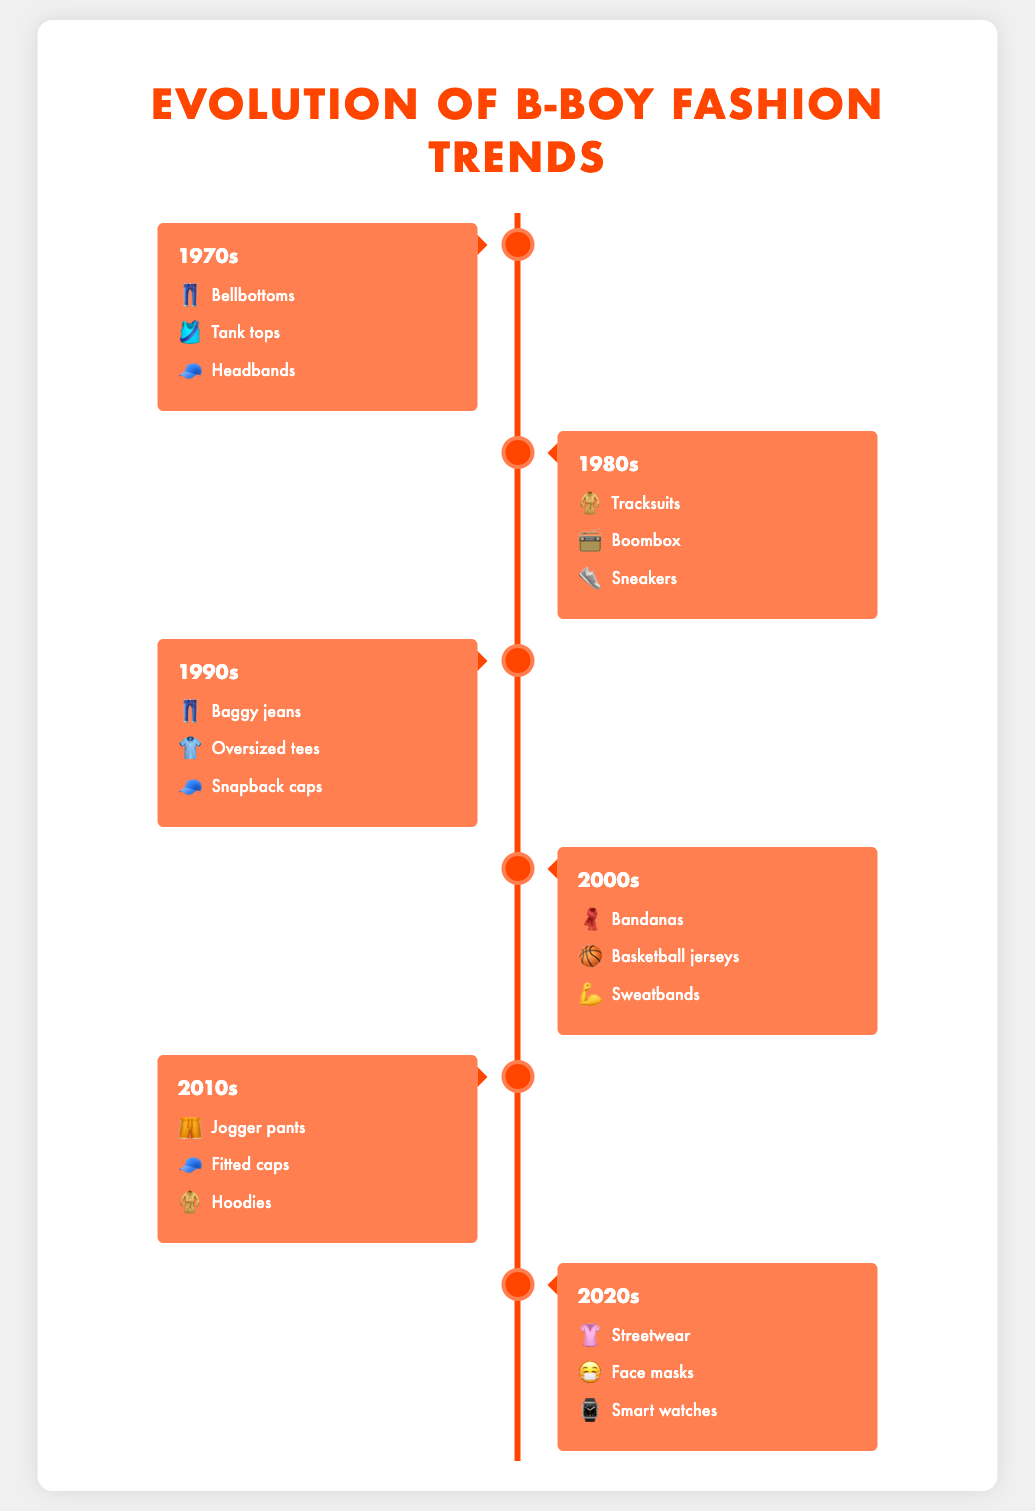Which era is associated with "Baggy jeans" 👖? In the figure, look for the decade that lists "Baggy jeans" along with its emoji.
Answer: 1990s In which era did "Hoodies" 🧥 become a trend? Scan each decade's fashion trends for "Hoodies" and its corresponding emoji.
Answer: 2010s Which items are trending in the 2020s era? Inspect the section labeled "2020s" to see the listed fashion items and their emojis.
Answer: Streetwear 👚, Face masks 😷, Smart watches ⌚ Compare the fashion item of 1970s and 2010s that shares the same emoji 🧢. Which item is it? Look at the items of 1970s and 2010s that use the emoji 🧢 and compare their names.
Answer: Headbands (1970s) and Fitted caps (2010s) How many distinct fashion items are mentioned in the 1980s era? Count the number of items listed under the "1980s" section.
Answer: 3 Identify the two eras where "Tracksuits" 🧥 and "Hoodies"🧥 were popular. Find the decades listing "Tracksuits" and "Hoodies" and note their respective eras.
Answer: Tracksuits: 1980s, Hoodies: 2010s Which era has an item associated with boombox 📻? Look through each decade till you find the fashion item "Boombox" and its emoji.
Answer: 1980s What common theme do the fashion items of the 2000s have compared to those of the 2020s? Evaluate the items of both eras and identify trends or elements that are prevalent in both.
Answer: Sports and accessory elements (2000s: Bandanas, Basketball jerseys, Sweatbands; 2020s: Streetwear, Face masks, Smart watches) Which eras feature headwear items, and what are the items? Look for all decades that list headwear items like caps, headbands, etc., and list them.
Answer: 1970s: Headbands 🧢; 1990s: Snapback caps 🧢; 2010s: Fitted caps 🧢 